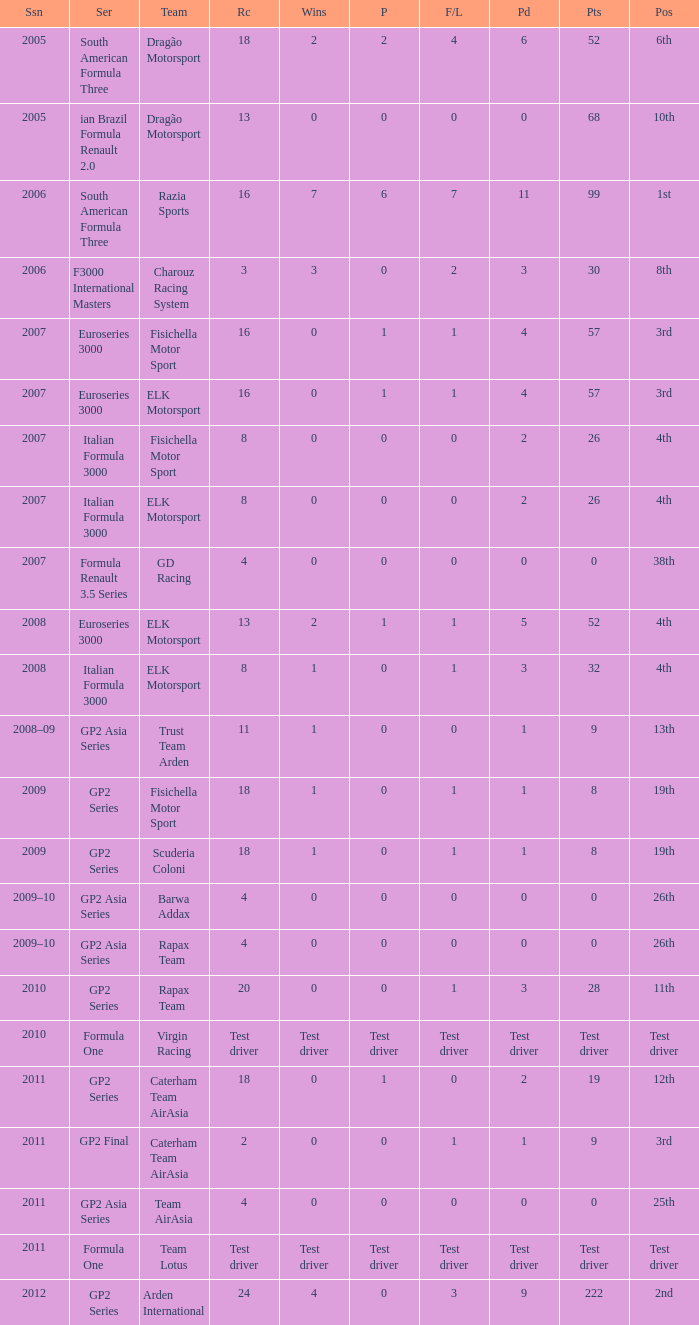What were the points in the year when his Podiums were 5? 52.0. 